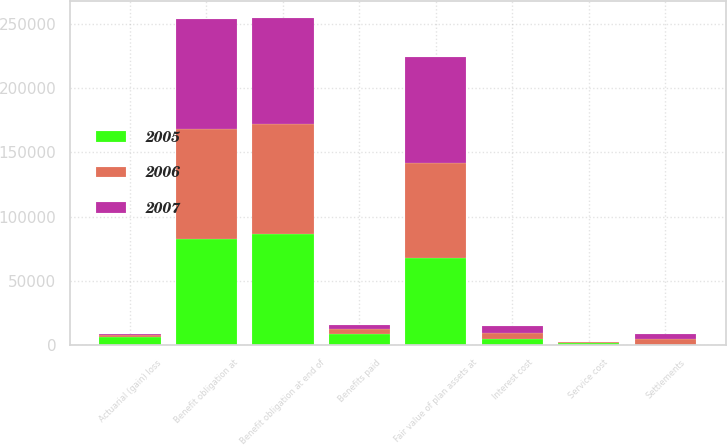Convert chart to OTSL. <chart><loc_0><loc_0><loc_500><loc_500><stacked_bar_chart><ecel><fcel>Benefit obligation at<fcel>Service cost<fcel>Interest cost<fcel>Actuarial (gain) loss<fcel>Benefits paid<fcel>Settlements<fcel>Benefit obligation at end of<fcel>Fair value of plan assets at<nl><fcel>2007<fcel>85523<fcel>463<fcel>4789<fcel>622<fcel>3591<fcel>3983<fcel>83001<fcel>82822<nl><fcel>2006<fcel>86205<fcel>487<fcel>4922<fcel>1973<fcel>3697<fcel>4367<fcel>85523<fcel>73931<nl><fcel>2005<fcel>82323<fcel>1665<fcel>4875<fcel>6121<fcel>8684<fcel>95<fcel>86205<fcel>67514<nl></chart> 